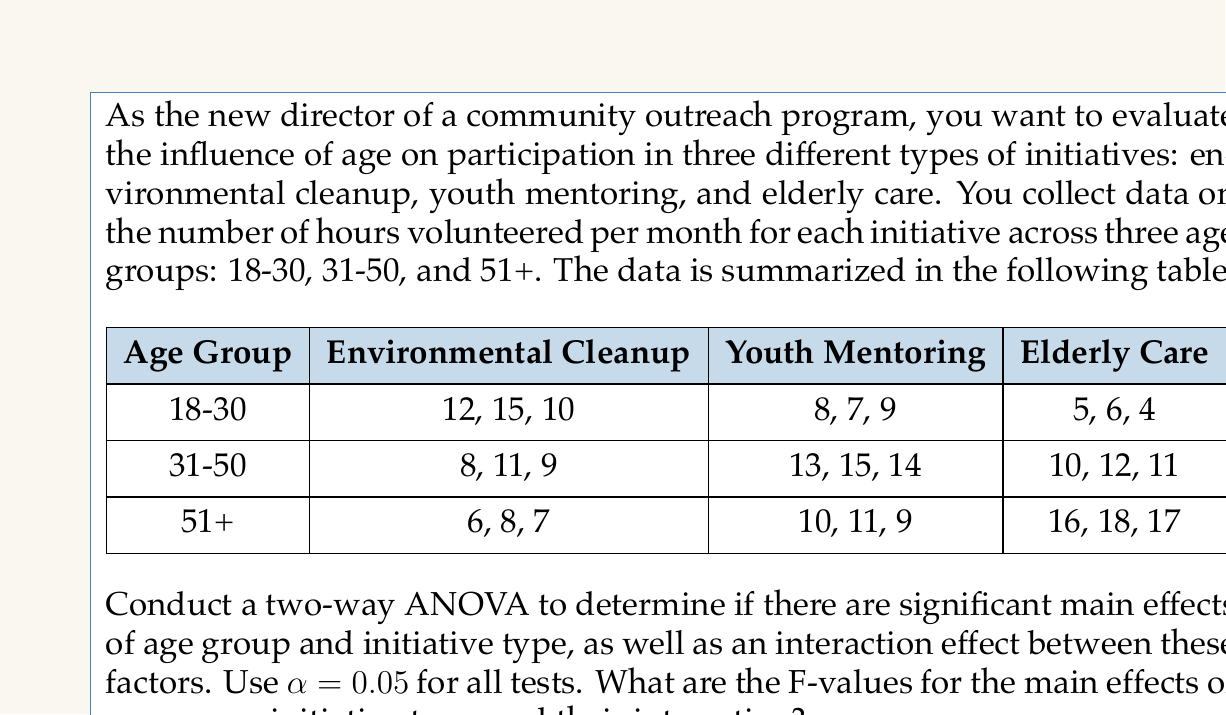What is the answer to this math problem? To conduct a two-way ANOVA, we need to calculate the following:

1. Sum of Squares (SS) for each factor and their interaction
2. Degrees of freedom (df) for each factor and their interaction
3. Mean Square (MS) for each factor and their interaction
4. F-values for each factor and their interaction

Step 1: Calculate the total sum of squares (SST)

First, we need to calculate the grand mean:
$$ \bar{X} = \frac{\text{Sum of all observations}}{\text{Total number of observations}} = \frac{261}{27} = 9.67 $$

Now, we can calculate SST:
$$ SST = \sum_{i=1}^{n} (X_i - \bar{X})^2 = 503.56 $$

Step 2: Calculate the sum of squares for age groups (SSA)

$$ SSA = n_j \sum_{j=1}^{a} (\bar{X}_j - \bar{X})^2 $$
Where $n_j$ is the number of observations in each age group (9), and $a$ is the number of age groups (3).

$$ SSA = 9 [(9.67 - 9.67)^2 + (11.44 - 9.67)^2 + (11.44 - 9.67)^2] = 28.67 $$

Step 3: Calculate the sum of squares for initiative types (SSB)

$$ SSB = n_k \sum_{k=1}^{b} (\bar{X}_k - \bar{X})^2 $$
Where $n_k$ is the number of observations in each initiative type (9), and $b$ is the number of initiative types (3).

$$ SSB = 9 [(10.22 - 9.67)^2 + (10.67 - 9.67)^2 + (11.00 - 9.67)^2] = 8.00 $$

Step 4: Calculate the sum of squares for interaction (SSAB)

$$ SSAB = \sum_{j=1}^{a} \sum_{k=1}^{b} n_{jk} (\bar{X}_{jk} - \bar{X}_j - \bar{X}_k + \bar{X})^2 $$

$$ SSAB = 374.67 $$

Step 5: Calculate the sum of squares for error (SSE)

$$ SSE = SST - SSA - SSB - SSAB = 503.56 - 28.67 - 8.00 - 374.67 = 92.22 $$

Step 6: Calculate degrees of freedom

- df(A) = a - 1 = 2
- df(B) = b - 1 = 2
- df(AB) = (a - 1)(b - 1) = 4
- df(E) = ab(n - 1) = 18
- df(T) = abn - 1 = 26

Step 7: Calculate Mean Squares

$$ MS_A = \frac{SSA}{df(A)} = \frac{28.67}{2} = 14.34 $$
$$ MS_B = \frac{SSB}{df(B)} = \frac{8.00}{2} = 4.00 $$
$$ MS_{AB} = \frac{SSAB}{df(AB)} = \frac{374.67}{4} = 93.67 $$
$$ MS_E = \frac{SSE}{df(E)} = \frac{92.22}{18} = 5.12 $$

Step 8: Calculate F-values

$$ F_A = \frac{MS_A}{MS_E} = \frac{14.34}{5.12} = 2.80 $$
$$ F_B = \frac{MS_B}{MS_E} = \frac{4.00}{5.12} = 0.78 $$
$$ F_{AB} = \frac{MS_{AB}}{MS_E} = \frac{93.67}{5.12} = 18.29 $$
Answer: The F-values for the main effects and interaction are:

- F-value for age group (main effect): 2.80
- F-value for initiative type (main effect): 0.78
- F-value for interaction between age group and initiative type: 18.29 